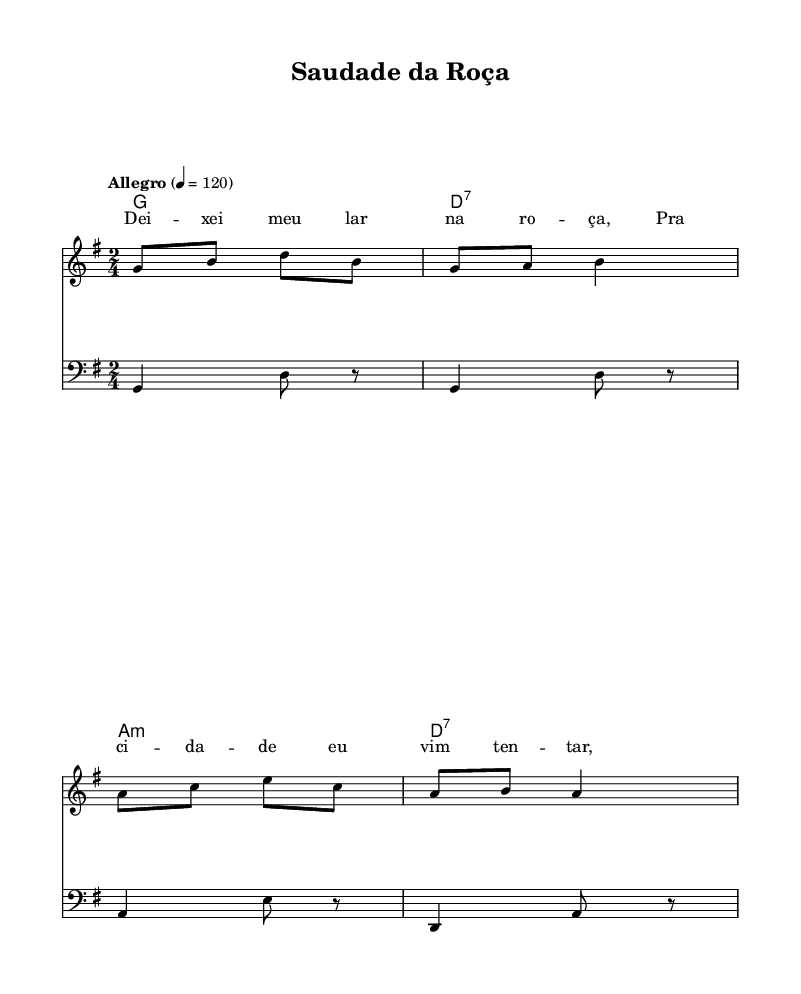What is the key signature of this music? The key signature is indicated at the beginning of the score and shows one sharp, which corresponds to G major.
Answer: G major What is the time signature of this music? The time signature is shown at the beginning of the score, represented by the 2/4 symbol, meaning there are two beats in each measure and the quarter note gets one beat.
Answer: 2/4 What is the tempo marking of this piece? The tempo marking "Allegro" indicates a lively and fast tempo, often interpreted as a range of 120 to 168 beats per minute. The specific marking of 4 = 120 shows the metronome setting for this tempo.
Answer: Allegro, 120 How many measures are in the melody section? Counting the measures in the melody, there are four distinct measures present in the melody part.
Answer: 4 What are the first two lyrics sung in this piece? The lyrics provided are in the verse section. The first two words are "Dei -- xei", indicating the opening of the song.
Answer: Dei -- xei What are the chord names used in this piece? The chord progression written in the harmonies section consists of G major, D7, A minor, and D7 again, which are specifically mentioned in the chord names written above the staff.
Answer: G, D7, A minor, D7 Why might the theme of migration be significant in this forró song? The migration theme reflects the personal experiences of those who have left rural areas for urban centers, often expressing nostalgia and longing for their homeland. This emotional connection is illustrated through the lyrics and melody, resonating with the cultural context of forró music in Brazil.
Answer: Nostalgia 